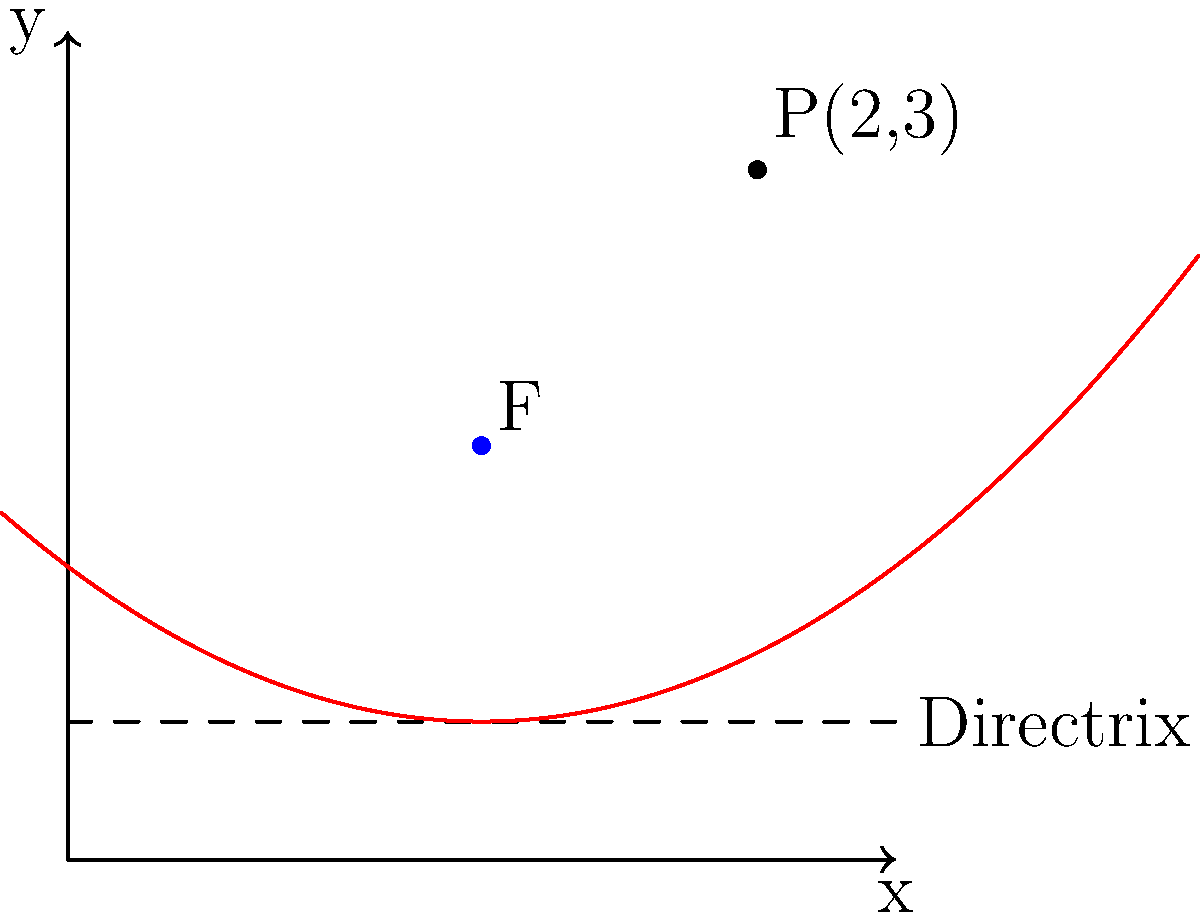During your university days with Kamer Nizamdeen, you both studied analytic geometry. Remembering those times, consider a parabola with focus F(0,1) and directrix y = -1. Find the equation of this parabola and determine if the point P(2,3) lies on it. Let's approach this step-by-step:

1) The general equation of a parabola with a vertical axis of symmetry is:
   $$(x-h)^2 = 4p(y-k)$$
   where (h,k) is the vertex and p is the distance from the vertex to the focus.

2) The focus is at (0,1) and the directrix is y = -1. The distance between these is 2.

3) The vertex is halfway between the focus and directrix:
   $k = \frac{1 + (-1)}{2} = 0$

4) Since the focus is directly above the vertex, h = 0.

5) The distance p from the vertex to the focus is half of the distance between focus and directrix:
   $p = \frac{2}{2} = 1$

6) Substituting these values into the general equation:
   $$(x-0)^2 = 4(1)(y-0)$$
   
7) Simplifying:
   $$x^2 = 4y$$

8) To check if P(2,3) is on the parabola, substitute its coordinates:
   $2^2 \stackrel{?}{=} 4(3)$
   $4 \neq 12$

Therefore, P(2,3) does not lie on the parabola.
Answer: $x^2 = 4y$; P(2,3) is not on the parabola. 